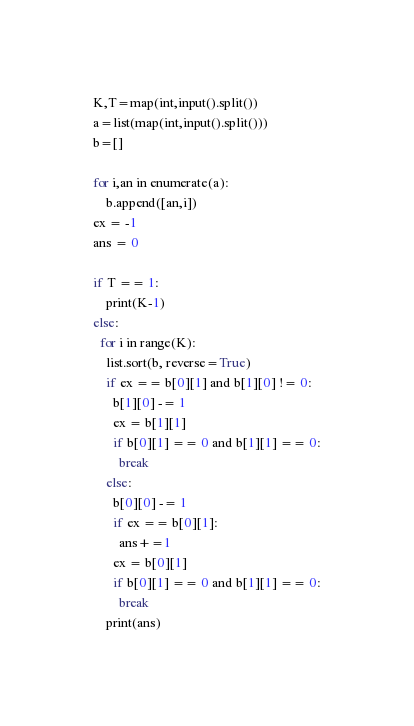Convert code to text. <code><loc_0><loc_0><loc_500><loc_500><_Python_>K,T=map(int,input().split())
a=list(map(int,input().split()))
b=[]

for i,an in enumerate(a):
    b.append([an,i])
ex = -1
ans = 0

if T == 1:
	print(K-1)
else:
  for i in range(K):
    list.sort(b, reverse=True)
    if ex == b[0][1] and b[1][0] != 0:
      b[1][0] -= 1
      ex = b[1][1]
      if b[0][1] == 0 and b[1][1] == 0:
        break
    else:
      b[0][0] -= 1
      if ex == b[0][1]:
        ans+=1
      ex = b[0][1]
      if b[0][1] == 0 and b[1][1] == 0:
        break
    print(ans)

</code> 